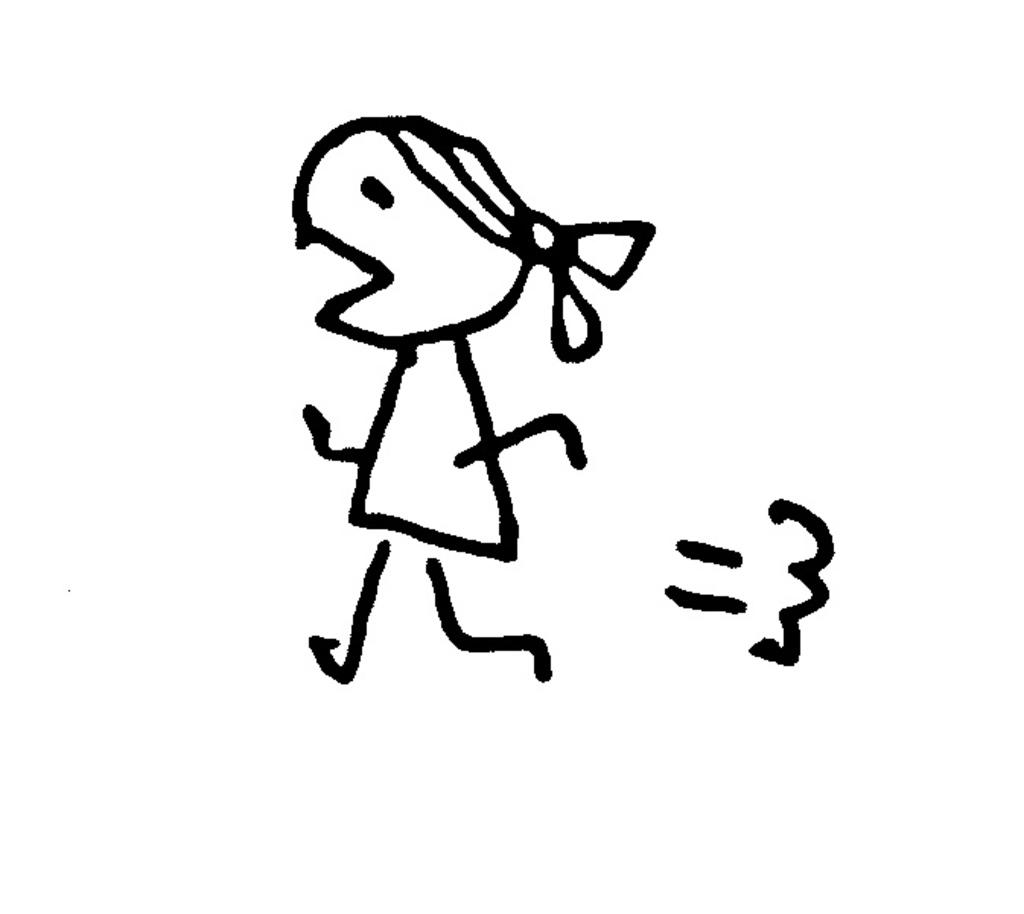What type of art is featured in the image? The image contains line art. What color is used for the line art? The line art is drawn in black color. What is the color of the background in the image? The background of the image is white in color. What type of error can be seen in the line art? There is no error present in the line art; it is a clean and well-drawn image. How does the line art roll across the white background? The line art does not roll across the white background, as it is a static image. 